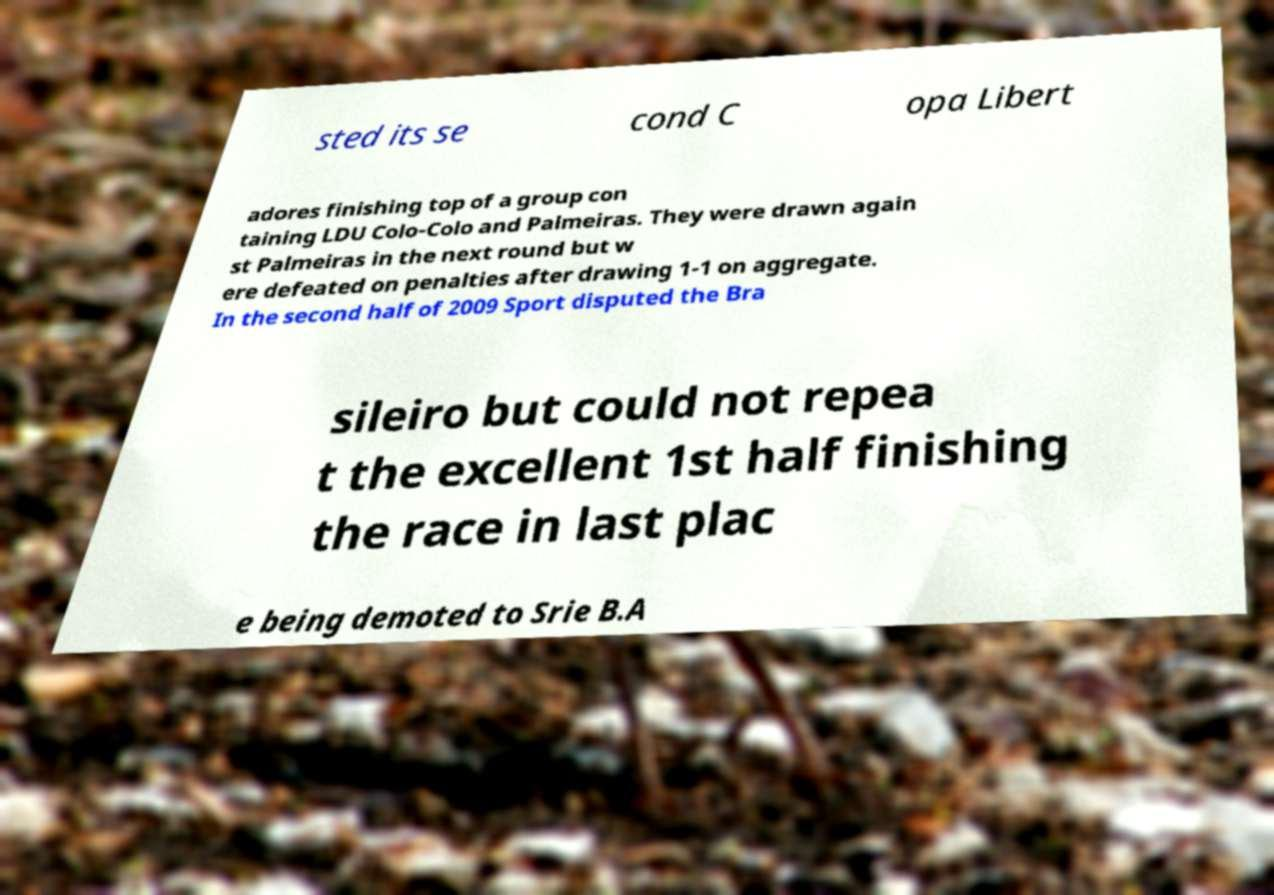Could you extract and type out the text from this image? sted its se cond C opa Libert adores finishing top of a group con taining LDU Colo-Colo and Palmeiras. They were drawn again st Palmeiras in the next round but w ere defeated on penalties after drawing 1-1 on aggregate. In the second half of 2009 Sport disputed the Bra sileiro but could not repea t the excellent 1st half finishing the race in last plac e being demoted to Srie B.A 